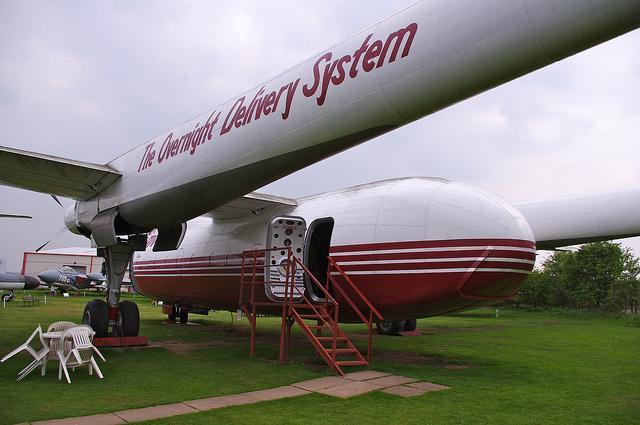How many chairs are there?
Give a very brief answer. 1. How many people are wearing white shirt?
Give a very brief answer. 0. 